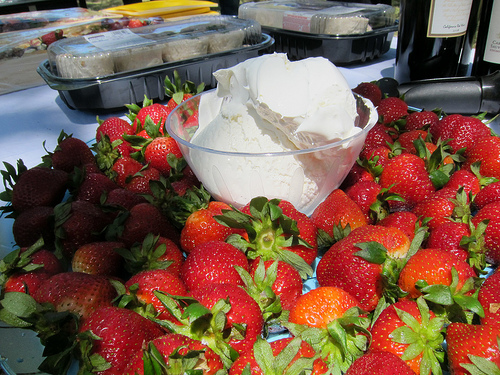<image>
Can you confirm if the strawberry is on the table? Yes. Looking at the image, I can see the strawberry is positioned on top of the table, with the table providing support. Is there a fruit under the wine? No. The fruit is not positioned under the wine. The vertical relationship between these objects is different. Is there a strawberry to the right of the icecream? Yes. From this viewpoint, the strawberry is positioned to the right side relative to the icecream. 